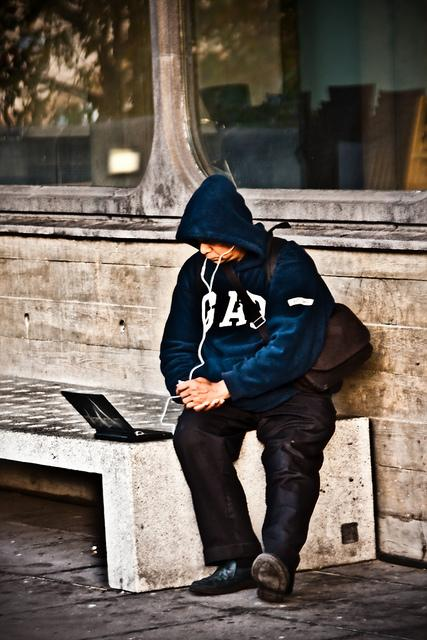What is the man sitting there doing? watching video 